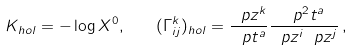Convert formula to latex. <formula><loc_0><loc_0><loc_500><loc_500>K _ { h o l } = - \log X ^ { 0 } , \quad ( \Gamma ^ { k } _ { i j } ) _ { h o l } = \frac { \ p z ^ { k } } { \ p t ^ { a } } \frac { \ p ^ { 2 } t ^ { a } } { \ p z ^ { i } \ p z ^ { j } } \, ,</formula> 